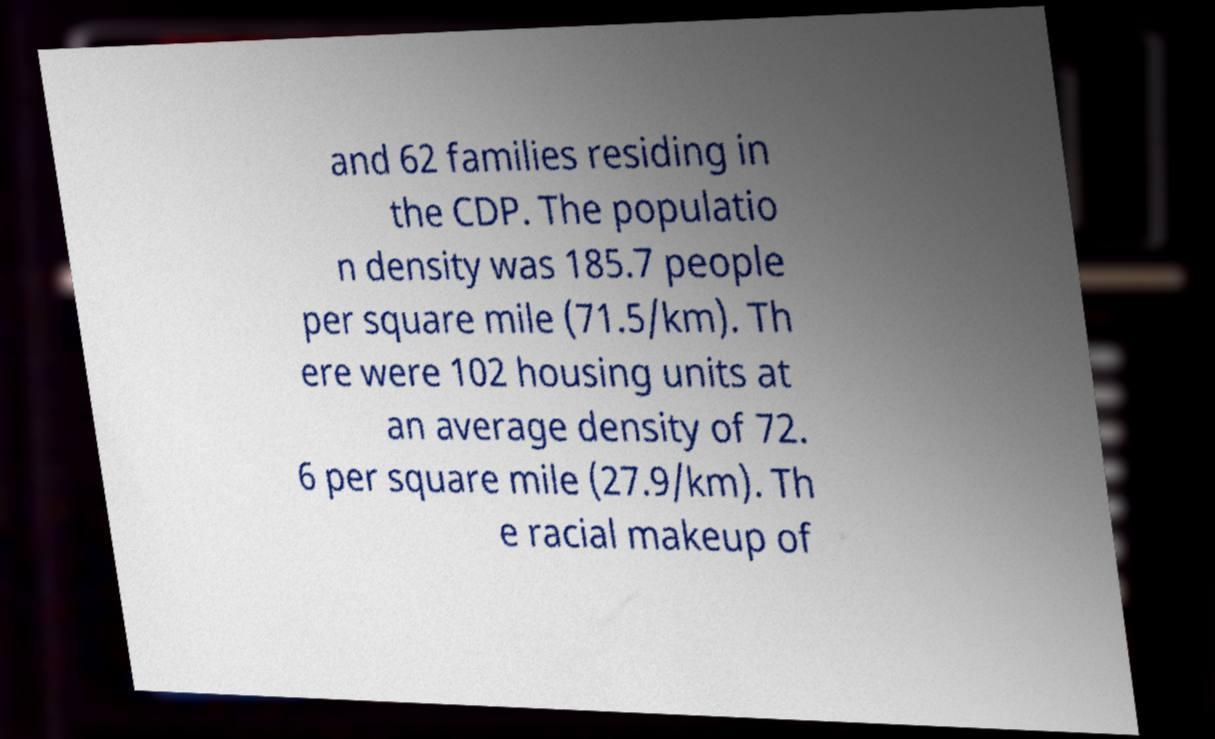Please identify and transcribe the text found in this image. and 62 families residing in the CDP. The populatio n density was 185.7 people per square mile (71.5/km). Th ere were 102 housing units at an average density of 72. 6 per square mile (27.9/km). Th e racial makeup of 